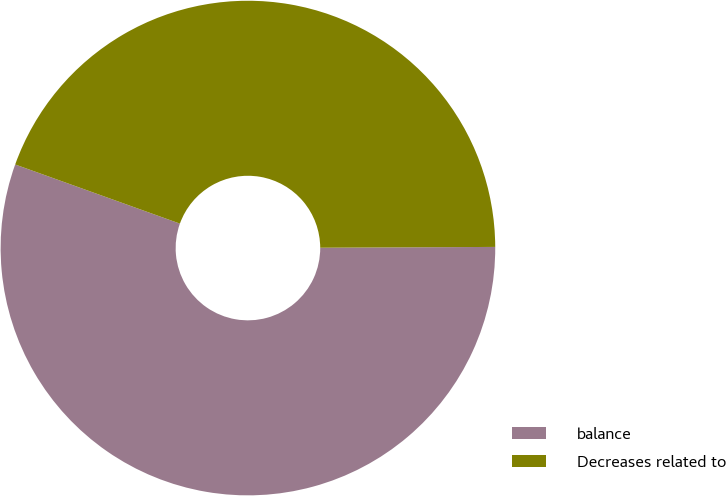Convert chart. <chart><loc_0><loc_0><loc_500><loc_500><pie_chart><fcel>balance<fcel>Decreases related to<nl><fcel>55.56%<fcel>44.44%<nl></chart> 